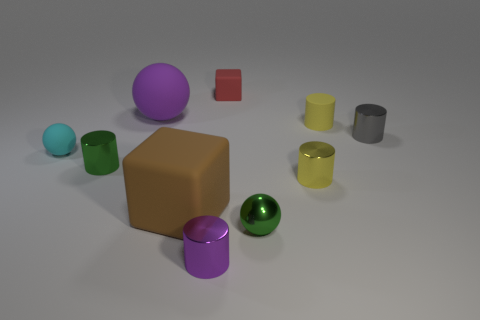Subtract all purple metallic cylinders. How many cylinders are left? 4 Subtract all gray cylinders. How many cylinders are left? 4 Subtract all cyan cylinders. Subtract all red blocks. How many cylinders are left? 5 Subtract all cubes. How many objects are left? 8 Add 6 big matte spheres. How many big matte spheres exist? 7 Subtract 1 green cylinders. How many objects are left? 9 Subtract all green things. Subtract all small red matte cubes. How many objects are left? 7 Add 2 small blocks. How many small blocks are left? 3 